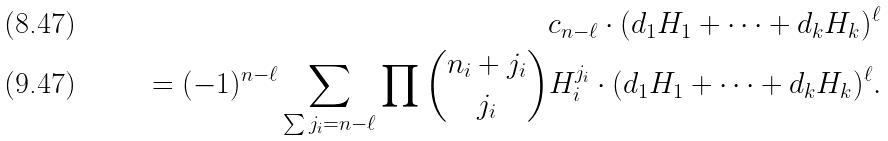Convert formula to latex. <formula><loc_0><loc_0><loc_500><loc_500>c _ { n - \ell } \cdot ( d _ { 1 } H _ { 1 } + \cdots + d _ { k } H _ { k } ) ^ { \ell } \\ = ( - 1 ) ^ { n - \ell } \sum _ { \sum j _ { i } = n - \ell } \prod \binom { n _ { i } + j _ { i } } { j _ { i } } H _ { i } ^ { j _ { i } } \cdot ( d _ { 1 } H _ { 1 } + \cdots + d _ { k } H _ { k } ) ^ { \ell } .</formula> 